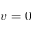Convert formula to latex. <formula><loc_0><loc_0><loc_500><loc_500>v = 0</formula> 